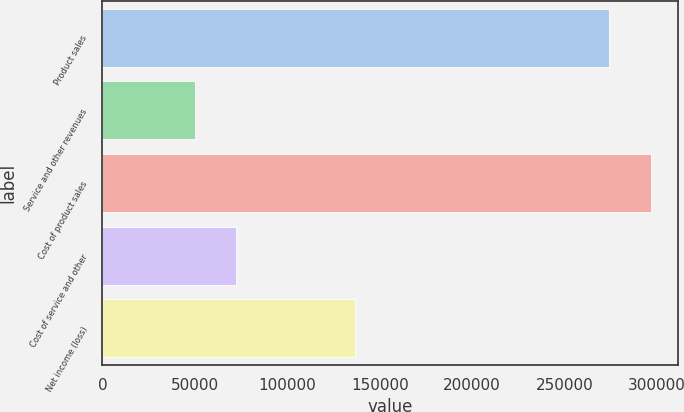<chart> <loc_0><loc_0><loc_500><loc_500><bar_chart><fcel>Product sales<fcel>Service and other revenues<fcel>Cost of product sales<fcel>Cost of service and other<fcel>Net income (loss)<nl><fcel>274128<fcel>50076<fcel>296533<fcel>72481.2<fcel>136835<nl></chart> 